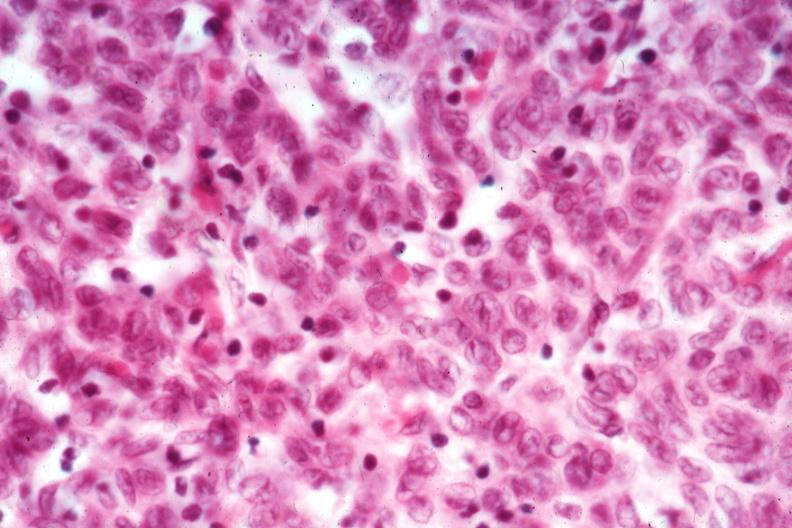what is present?
Answer the question using a single word or phrase. Thymoma 